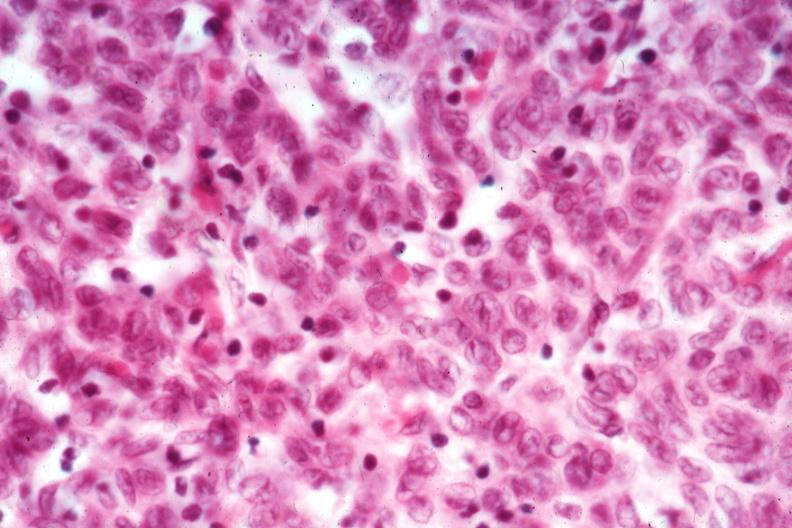what is present?
Answer the question using a single word or phrase. Thymoma 